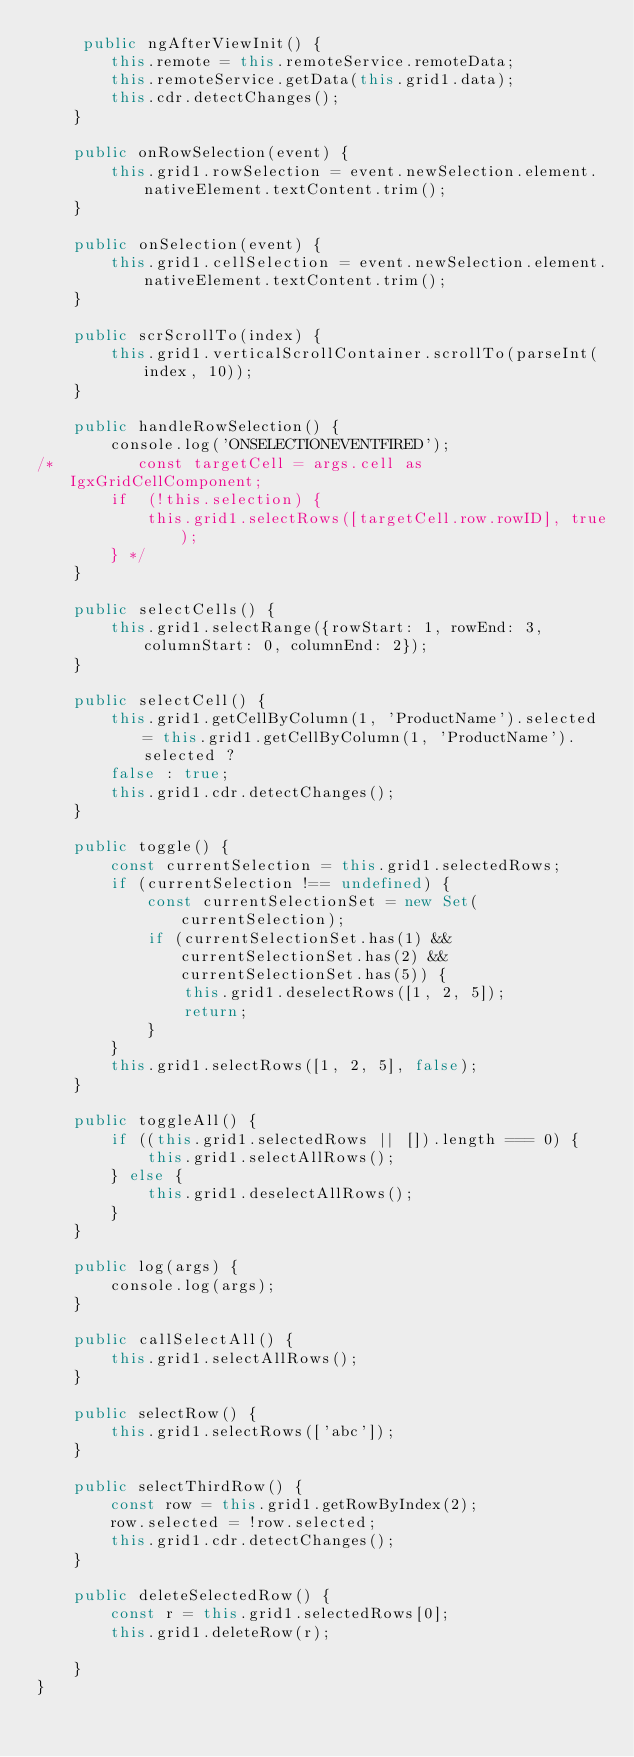<code> <loc_0><loc_0><loc_500><loc_500><_TypeScript_>     public ngAfterViewInit() {
        this.remote = this.remoteService.remoteData;
        this.remoteService.getData(this.grid1.data);
        this.cdr.detectChanges();
    }

    public onRowSelection(event) {
        this.grid1.rowSelection = event.newSelection.element.nativeElement.textContent.trim();
    }

    public onSelection(event) {
        this.grid1.cellSelection = event.newSelection.element.nativeElement.textContent.trim();
    }

    public scrScrollTo(index) {
        this.grid1.verticalScrollContainer.scrollTo(parseInt(index, 10));
    }

    public handleRowSelection() {
        console.log('ONSELECTIONEVENTFIRED');
/*         const targetCell = args.cell as IgxGridCellComponent;
        if  (!this.selection) {
            this.grid1.selectRows([targetCell.row.rowID], true);
        } */
    }

    public selectCells() {
        this.grid1.selectRange({rowStart: 1, rowEnd: 3, columnStart: 0, columnEnd: 2});
    }

    public selectCell() {
        this.grid1.getCellByColumn(1, 'ProductName').selected = this.grid1.getCellByColumn(1, 'ProductName').selected ?
        false : true;
        this.grid1.cdr.detectChanges();
    }

    public toggle() {
        const currentSelection = this.grid1.selectedRows;
        if (currentSelection !== undefined) {
            const currentSelectionSet = new Set(currentSelection);
            if (currentSelectionSet.has(1) && currentSelectionSet.has(2) && currentSelectionSet.has(5)) {
                this.grid1.deselectRows([1, 2, 5]);
                return;
            }
        }
        this.grid1.selectRows([1, 2, 5], false);
    }

    public toggleAll() {
        if ((this.grid1.selectedRows || []).length === 0) {
            this.grid1.selectAllRows();
        } else {
            this.grid1.deselectAllRows();
        }
    }

    public log(args) {
        console.log(args);
    }

    public callSelectAll() {
        this.grid1.selectAllRows();
    }

    public selectRow() {
        this.grid1.selectRows(['abc']);
    }

    public selectThirdRow() {
        const row = this.grid1.getRowByIndex(2);
        row.selected = !row.selected;
        this.grid1.cdr.detectChanges();
    }

    public deleteSelectedRow() {
        const r = this.grid1.selectedRows[0];
        this.grid1.deleteRow(r);

    }
}
</code> 